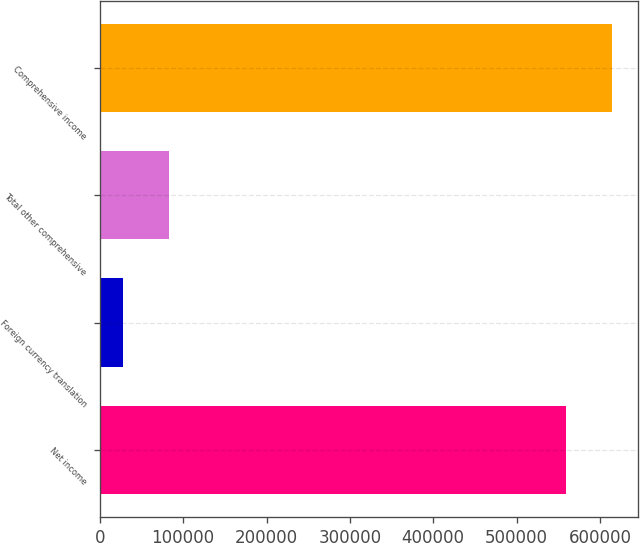Convert chart to OTSL. <chart><loc_0><loc_0><loc_500><loc_500><bar_chart><fcel>Net income<fcel>Foreign currency translation<fcel>Total other comprehensive<fcel>Comprehensive income<nl><fcel>558929<fcel>27409<fcel>83361.8<fcel>614882<nl></chart> 